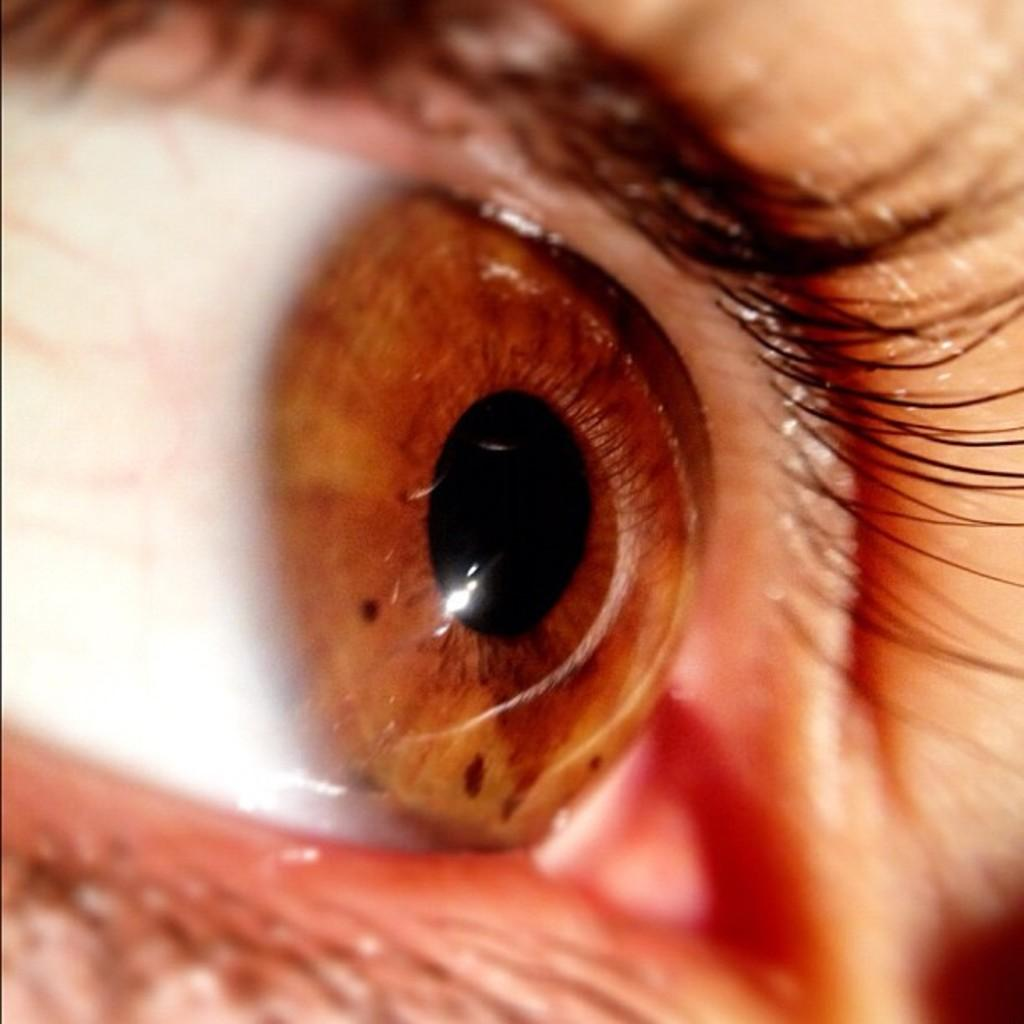What is the main subject of the image? The main subject of the image is a person's eye. Can you describe any specific features of the eye in the image? Unfortunately, the image is a zoomed-in picture, so it is difficult to describe any specific features of the eye. How many sticks are visible in the image? There are no sticks present in the image; it is a close-up picture of a person's eye. What mark can be seen on the fifth eyelash in the image? There are no eyelashes visible in the image, as it is a close-up picture of the eye itself. 